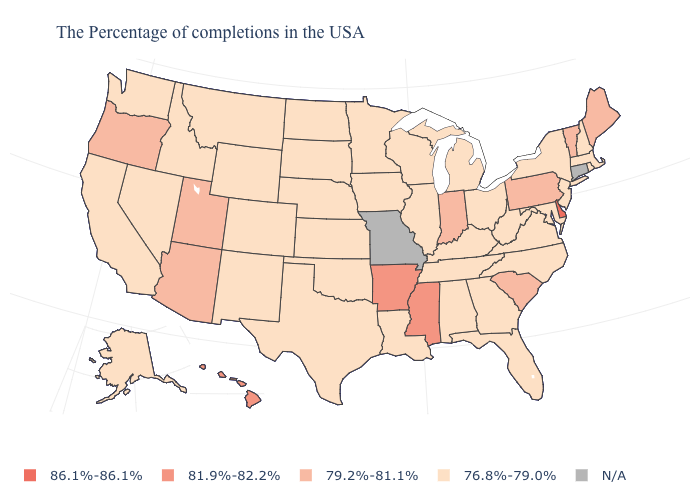Does the map have missing data?
Write a very short answer. Yes. What is the lowest value in the USA?
Short answer required. 76.8%-79.0%. Is the legend a continuous bar?
Be succinct. No. Name the states that have a value in the range 76.8%-79.0%?
Give a very brief answer. Massachusetts, Rhode Island, New Hampshire, New York, New Jersey, Maryland, Virginia, North Carolina, West Virginia, Ohio, Florida, Georgia, Michigan, Kentucky, Alabama, Tennessee, Wisconsin, Illinois, Louisiana, Minnesota, Iowa, Kansas, Nebraska, Oklahoma, Texas, South Dakota, North Dakota, Wyoming, Colorado, New Mexico, Montana, Idaho, Nevada, California, Washington, Alaska. Among the states that border Wisconsin , which have the highest value?
Quick response, please. Michigan, Illinois, Minnesota, Iowa. Name the states that have a value in the range 86.1%-86.1%?
Give a very brief answer. Delaware. Among the states that border Arkansas , which have the highest value?
Give a very brief answer. Mississippi. What is the lowest value in the Northeast?
Concise answer only. 76.8%-79.0%. Among the states that border New Hampshire , which have the lowest value?
Be succinct. Massachusetts. Among the states that border Illinois , which have the highest value?
Answer briefly. Indiana. What is the lowest value in the MidWest?
Keep it brief. 76.8%-79.0%. What is the value of Idaho?
Write a very short answer. 76.8%-79.0%. 